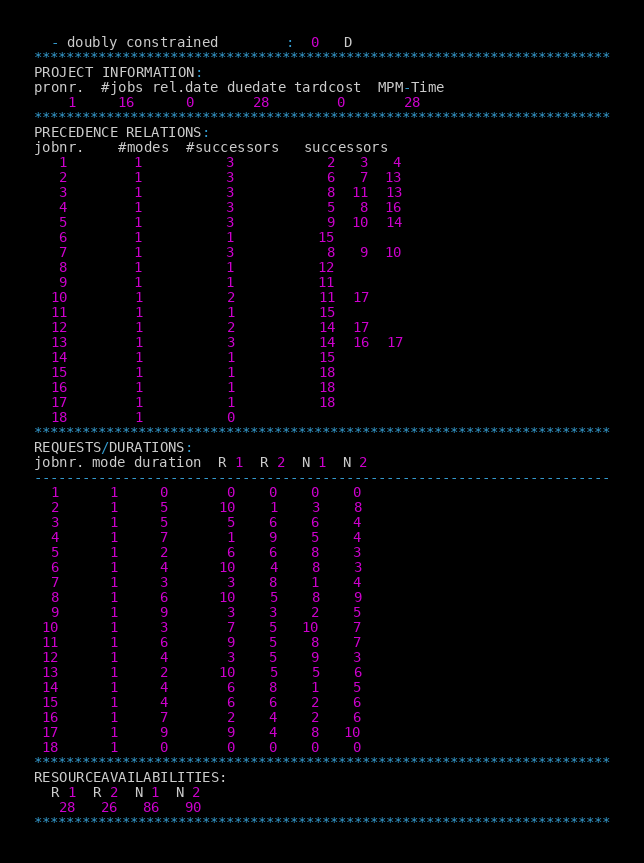Convert code to text. <code><loc_0><loc_0><loc_500><loc_500><_ObjectiveC_>  - doubly constrained        :  0   D
************************************************************************
PROJECT INFORMATION:
pronr.  #jobs rel.date duedate tardcost  MPM-Time
    1     16      0       28        0       28
************************************************************************
PRECEDENCE RELATIONS:
jobnr.    #modes  #successors   successors
   1        1          3           2   3   4
   2        1          3           6   7  13
   3        1          3           8  11  13
   4        1          3           5   8  16
   5        1          3           9  10  14
   6        1          1          15
   7        1          3           8   9  10
   8        1          1          12
   9        1          1          11
  10        1          2          11  17
  11        1          1          15
  12        1          2          14  17
  13        1          3          14  16  17
  14        1          1          15
  15        1          1          18
  16        1          1          18
  17        1          1          18
  18        1          0        
************************************************************************
REQUESTS/DURATIONS:
jobnr. mode duration  R 1  R 2  N 1  N 2
------------------------------------------------------------------------
  1      1     0       0    0    0    0
  2      1     5      10    1    3    8
  3      1     5       5    6    6    4
  4      1     7       1    9    5    4
  5      1     2       6    6    8    3
  6      1     4      10    4    8    3
  7      1     3       3    8    1    4
  8      1     6      10    5    8    9
  9      1     9       3    3    2    5
 10      1     3       7    5   10    7
 11      1     6       9    5    8    7
 12      1     4       3    5    9    3
 13      1     2      10    5    5    6
 14      1     4       6    8    1    5
 15      1     4       6    6    2    6
 16      1     7       2    4    2    6
 17      1     9       9    4    8   10
 18      1     0       0    0    0    0
************************************************************************
RESOURCEAVAILABILITIES:
  R 1  R 2  N 1  N 2
   28   26   86   90
************************************************************************
</code> 